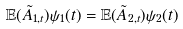Convert formula to latex. <formula><loc_0><loc_0><loc_500><loc_500>\mathbb { E } ( \tilde { A } _ { 1 , t } ) \psi _ { 1 } ( t ) = \mathbb { E } ( \tilde { A } _ { 2 , t } ) \psi _ { 2 } ( t )</formula> 